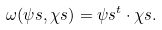Convert formula to latex. <formula><loc_0><loc_0><loc_500><loc_500>\omega ( \psi s , \chi s ) = \psi s ^ { t } \cdot \chi s .</formula> 